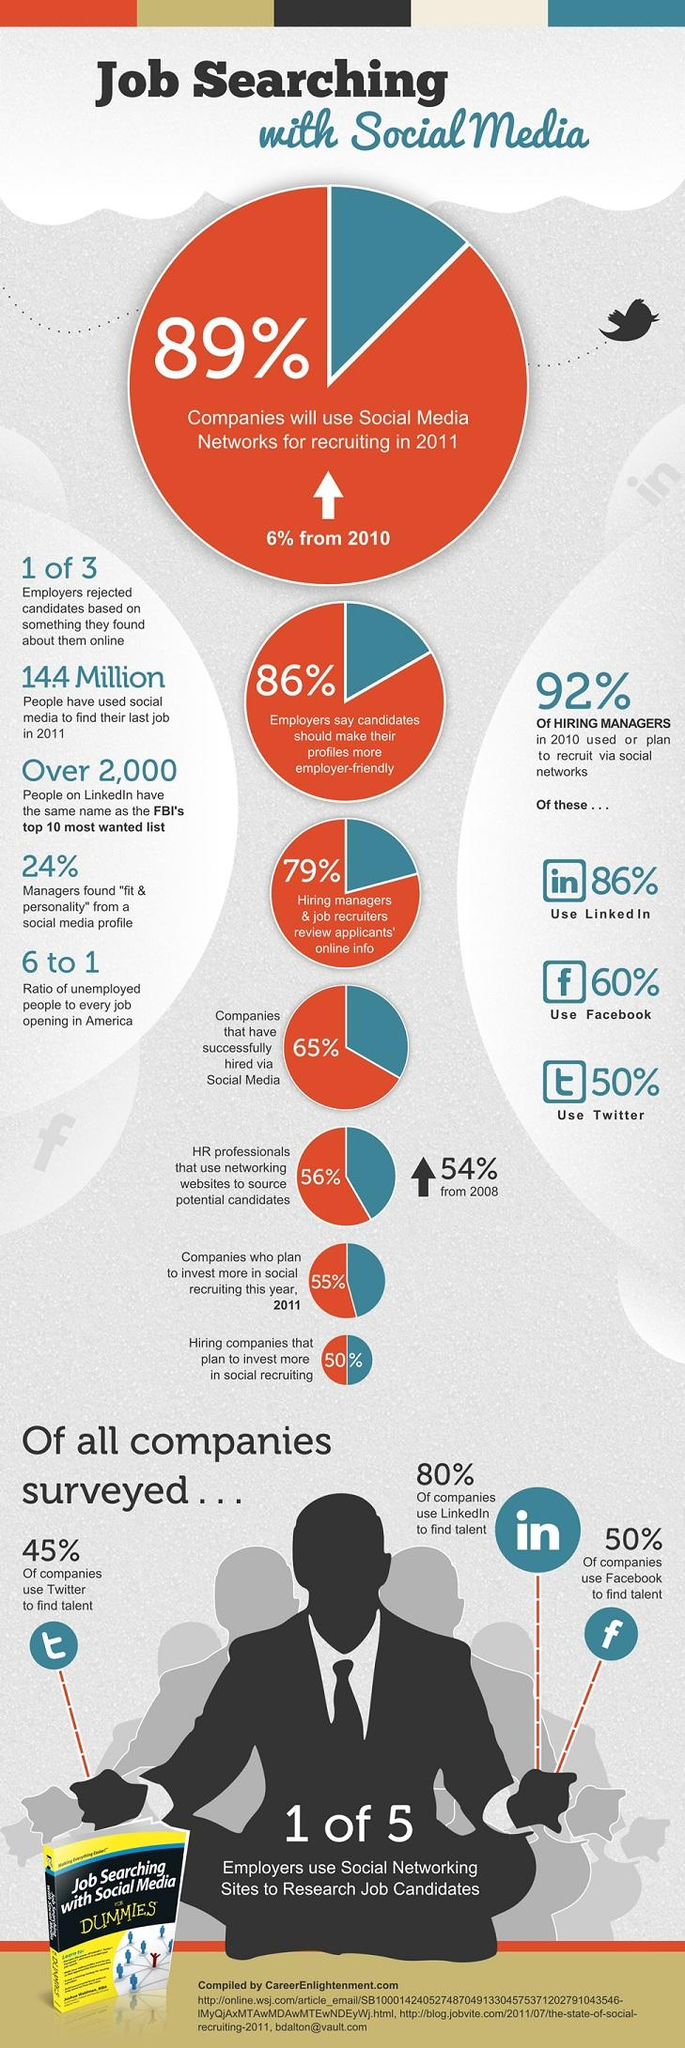Identify some key points in this picture. The book title is 'Job Searching with Social Media FOR DUMMIES', which provides guidance on utilizing social media platforms for effective job searching. According to the statistic, only 11% of companies are not using social media for recruiting purposes. 